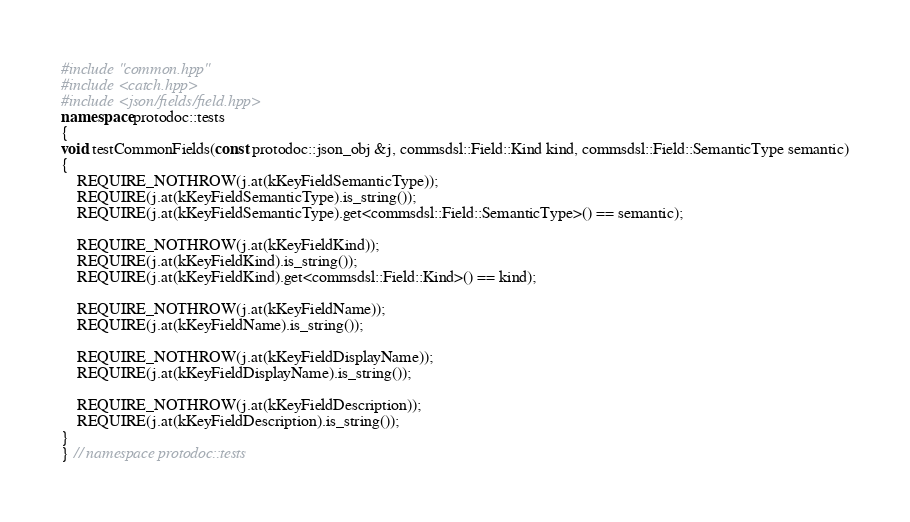Convert code to text. <code><loc_0><loc_0><loc_500><loc_500><_C++_>#include "common.hpp"
#include <catch.hpp>
#include <json/fields/field.hpp>
namespace protodoc::tests
{
void testCommonFields(const protodoc::json_obj &j, commsdsl::Field::Kind kind, commsdsl::Field::SemanticType semantic)
{
    REQUIRE_NOTHROW(j.at(kKeyFieldSemanticType));
    REQUIRE(j.at(kKeyFieldSemanticType).is_string());
    REQUIRE(j.at(kKeyFieldSemanticType).get<commsdsl::Field::SemanticType>() == semantic);

    REQUIRE_NOTHROW(j.at(kKeyFieldKind));
    REQUIRE(j.at(kKeyFieldKind).is_string());
    REQUIRE(j.at(kKeyFieldKind).get<commsdsl::Field::Kind>() == kind);

    REQUIRE_NOTHROW(j.at(kKeyFieldName));
    REQUIRE(j.at(kKeyFieldName).is_string());

    REQUIRE_NOTHROW(j.at(kKeyFieldDisplayName));
    REQUIRE(j.at(kKeyFieldDisplayName).is_string());

    REQUIRE_NOTHROW(j.at(kKeyFieldDescription));
    REQUIRE(j.at(kKeyFieldDescription).is_string());
}
} // namespace protodoc::tests
</code> 